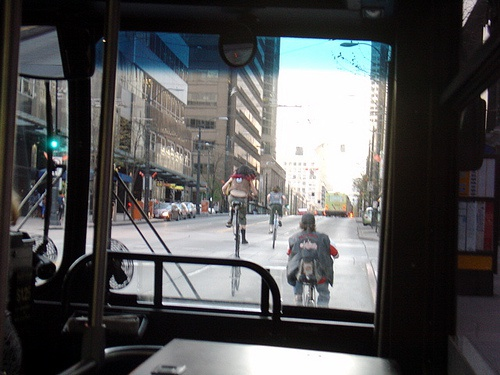Describe the objects in this image and their specific colors. I can see people in black, gray, darkgray, and purple tones, people in black, gray, and darkgray tones, backpack in black, gray, darkgray, and purple tones, bus in black, beige, darkgray, and gray tones, and people in black, gray, darkgray, and lightgray tones in this image. 